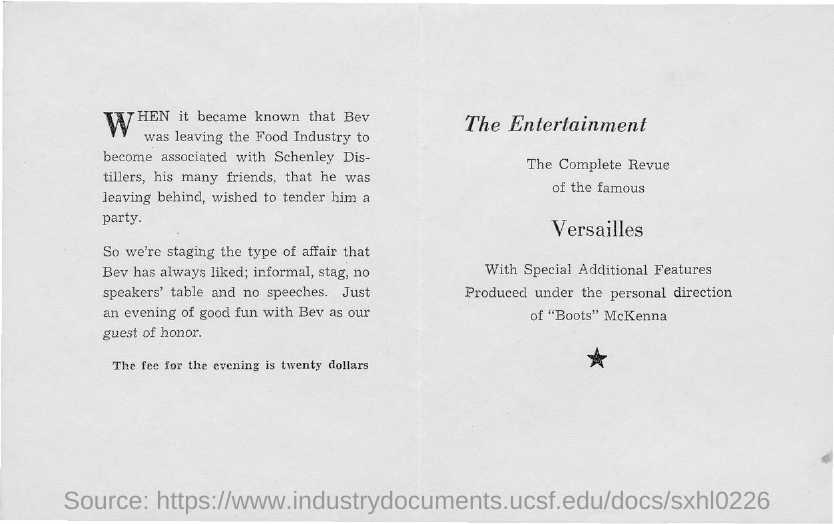List a handful of essential elements in this visual. The Entertainment Industry is the first title in the document. 